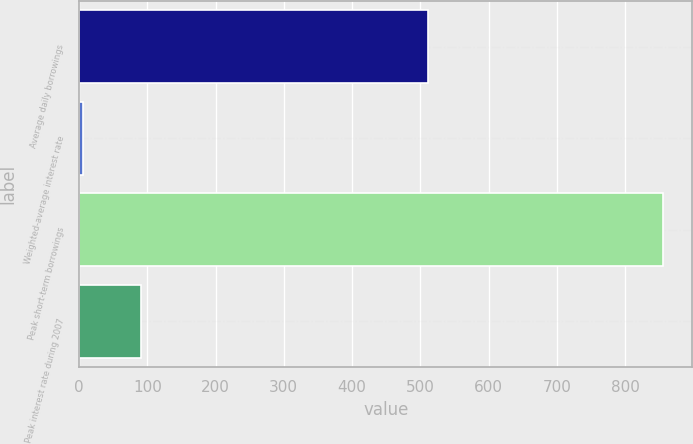Convert chart. <chart><loc_0><loc_0><loc_500><loc_500><bar_chart><fcel>Average daily borrowings<fcel>Weighted-average interest rate<fcel>Peak short-term borrowings<fcel>Peak interest rate during 2007<nl><fcel>512<fcel>5.68<fcel>856<fcel>90.71<nl></chart> 